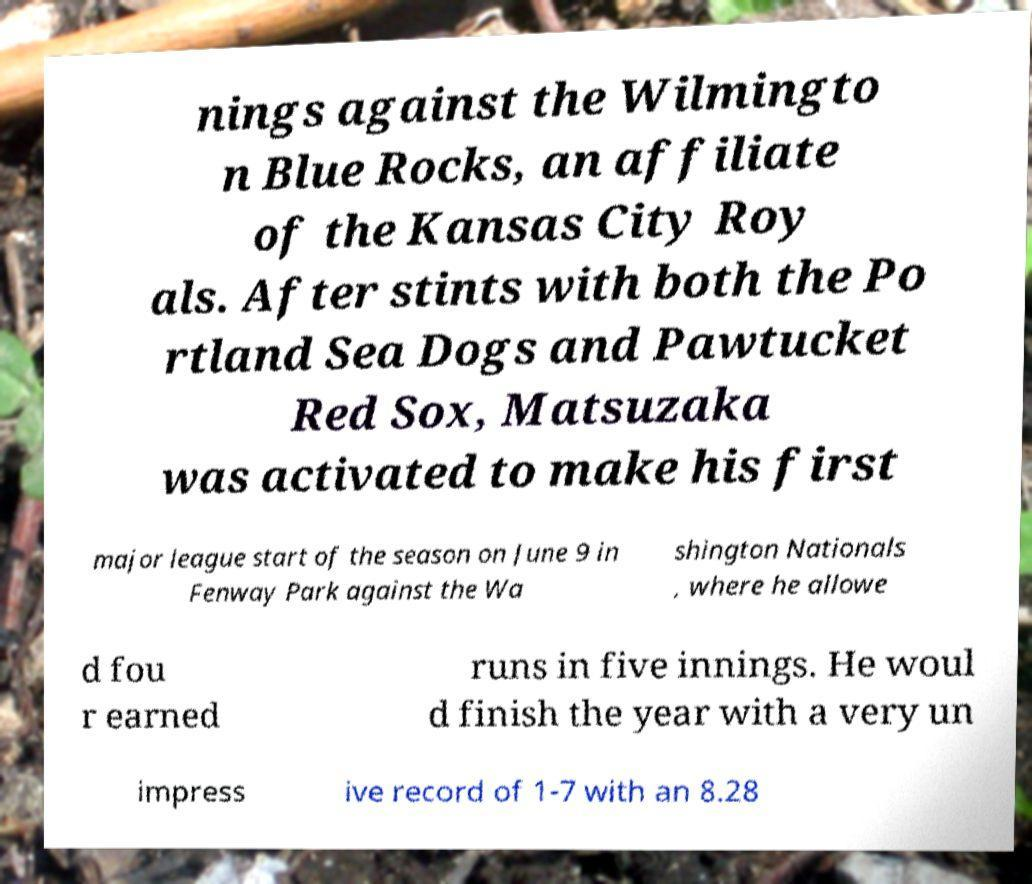Please identify and transcribe the text found in this image. nings against the Wilmingto n Blue Rocks, an affiliate of the Kansas City Roy als. After stints with both the Po rtland Sea Dogs and Pawtucket Red Sox, Matsuzaka was activated to make his first major league start of the season on June 9 in Fenway Park against the Wa shington Nationals , where he allowe d fou r earned runs in five innings. He woul d finish the year with a very un impress ive record of 1-7 with an 8.28 